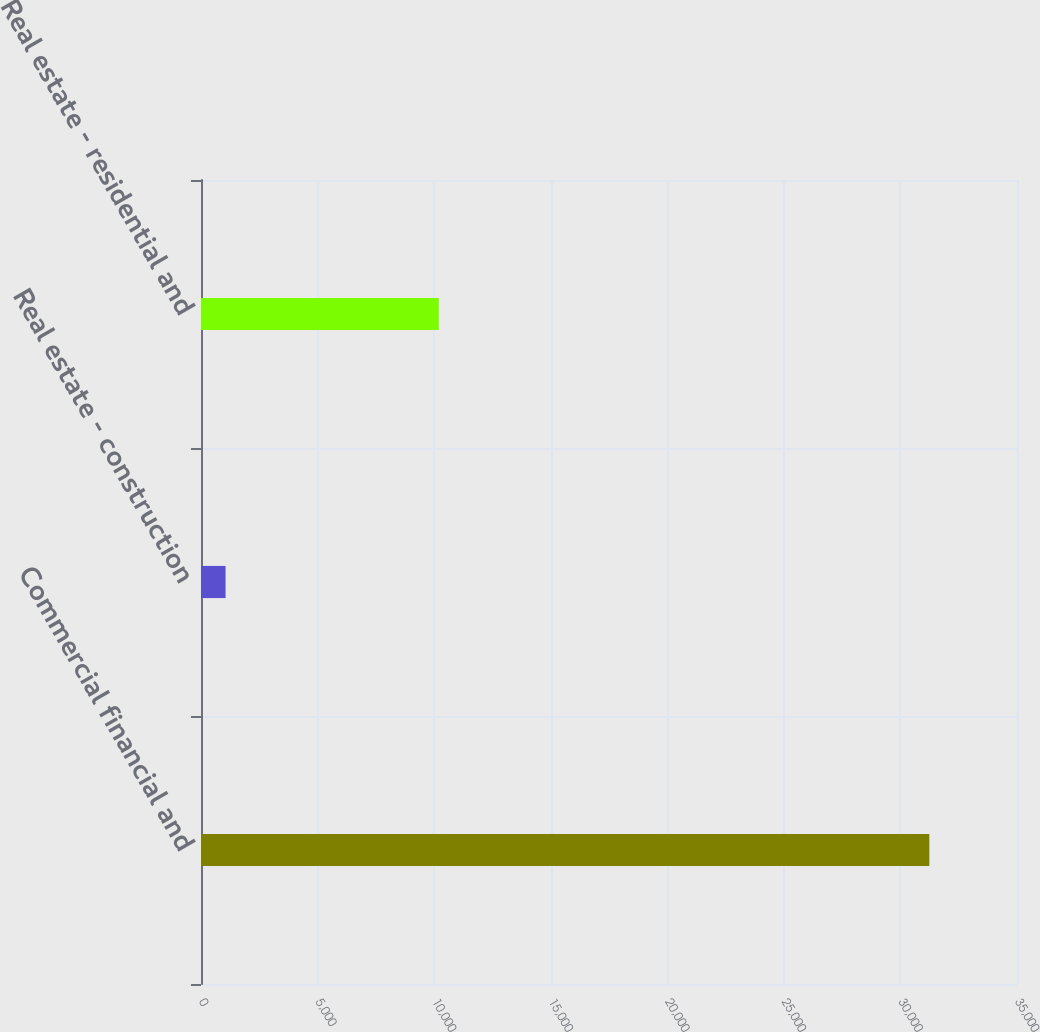Convert chart to OTSL. <chart><loc_0><loc_0><loc_500><loc_500><bar_chart><fcel>Commercial financial and<fcel>Real estate - construction<fcel>Real estate - residential and<nl><fcel>31240<fcel>1053<fcel>10201<nl></chart> 